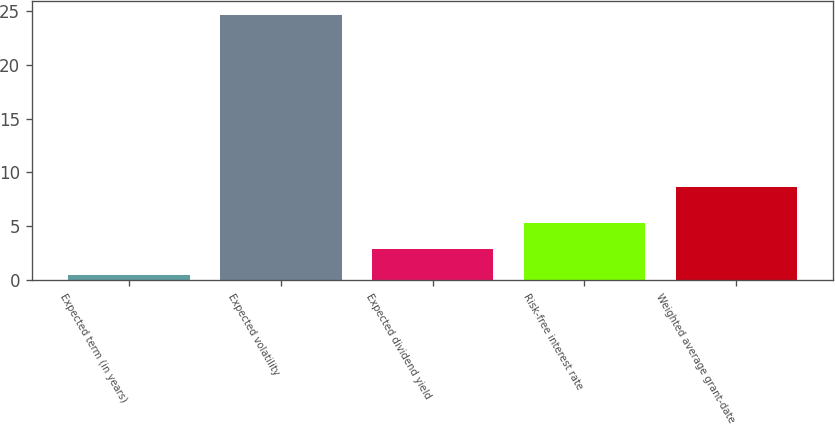<chart> <loc_0><loc_0><loc_500><loc_500><bar_chart><fcel>Expected term (in years)<fcel>Expected volatility<fcel>Expected dividend yield<fcel>Risk-free interest rate<fcel>Weighted average grant-date<nl><fcel>0.5<fcel>24.69<fcel>2.92<fcel>5.34<fcel>8.64<nl></chart> 